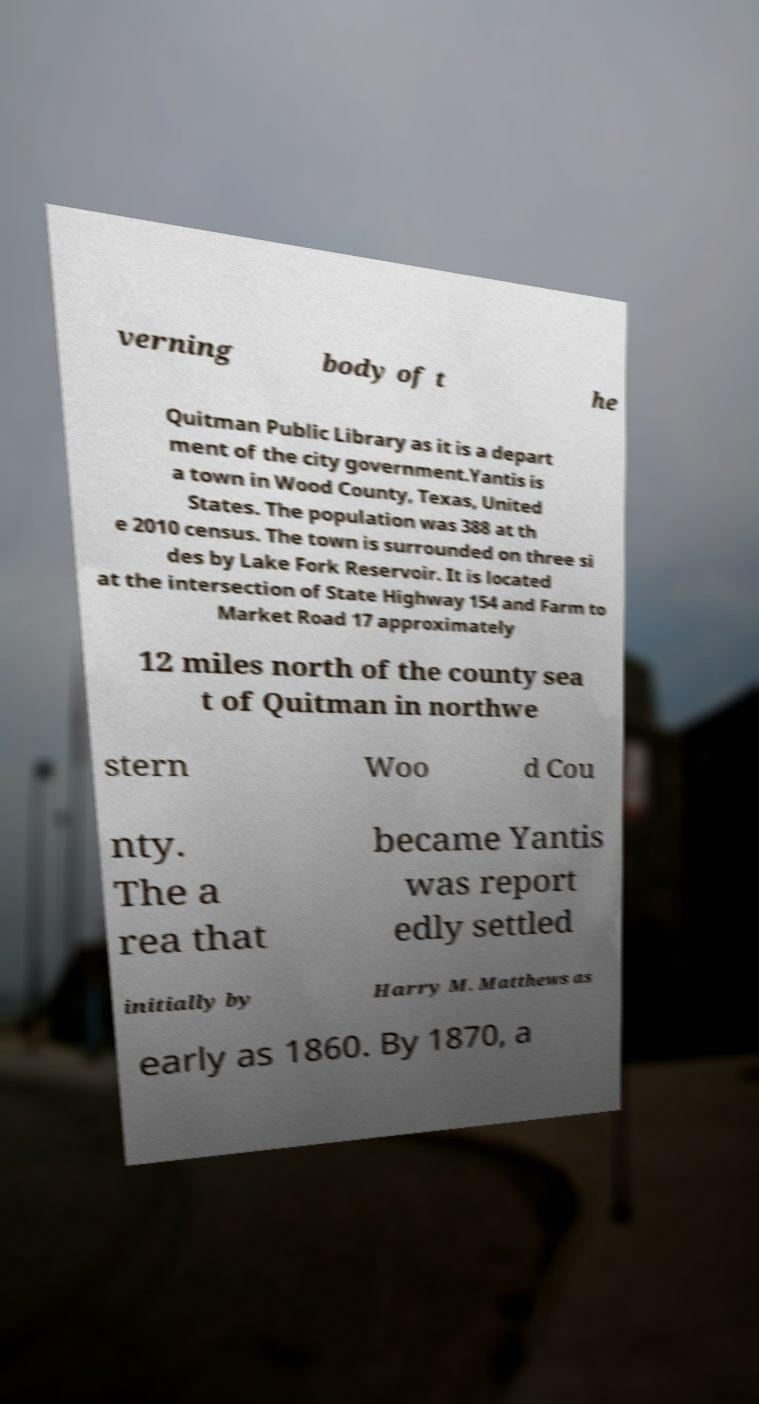What messages or text are displayed in this image? I need them in a readable, typed format. verning body of t he Quitman Public Library as it is a depart ment of the city government.Yantis is a town in Wood County, Texas, United States. The population was 388 at th e 2010 census. The town is surrounded on three si des by Lake Fork Reservoir. It is located at the intersection of State Highway 154 and Farm to Market Road 17 approximately 12 miles north of the county sea t of Quitman in northwe stern Woo d Cou nty. The a rea that became Yantis was report edly settled initially by Harry M. Matthews as early as 1860. By 1870, a 